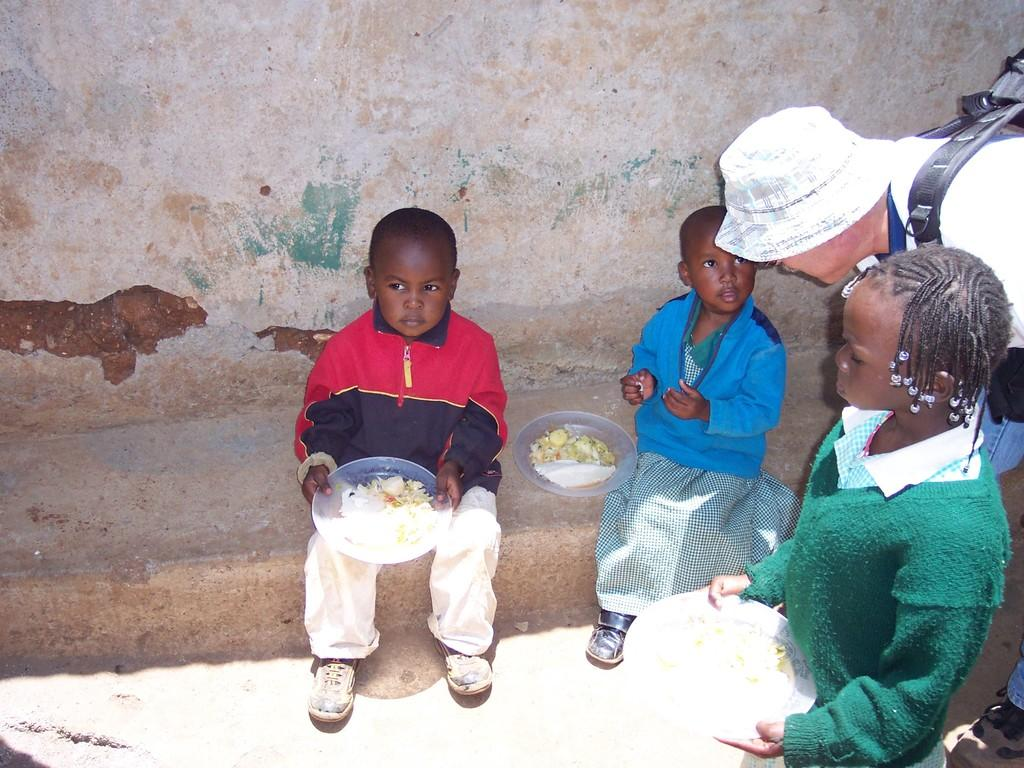How many kids are sitting in the image? There are two kids sitting in the image. What is the boy holding in his hands? The boy is holding a plate in his hands. Can you describe the girl in the image? There is a girl in the image, and she is also holding a plate. What else can be seen in the image besides the kids? A person is standing in the image, and there is a wall visible as well. What type of organization is taking place at the seashore in the image? There is no seashore present in the image, and no organization is taking place. Is there any snow visible in the image? No, there is no snow visible in the image. 